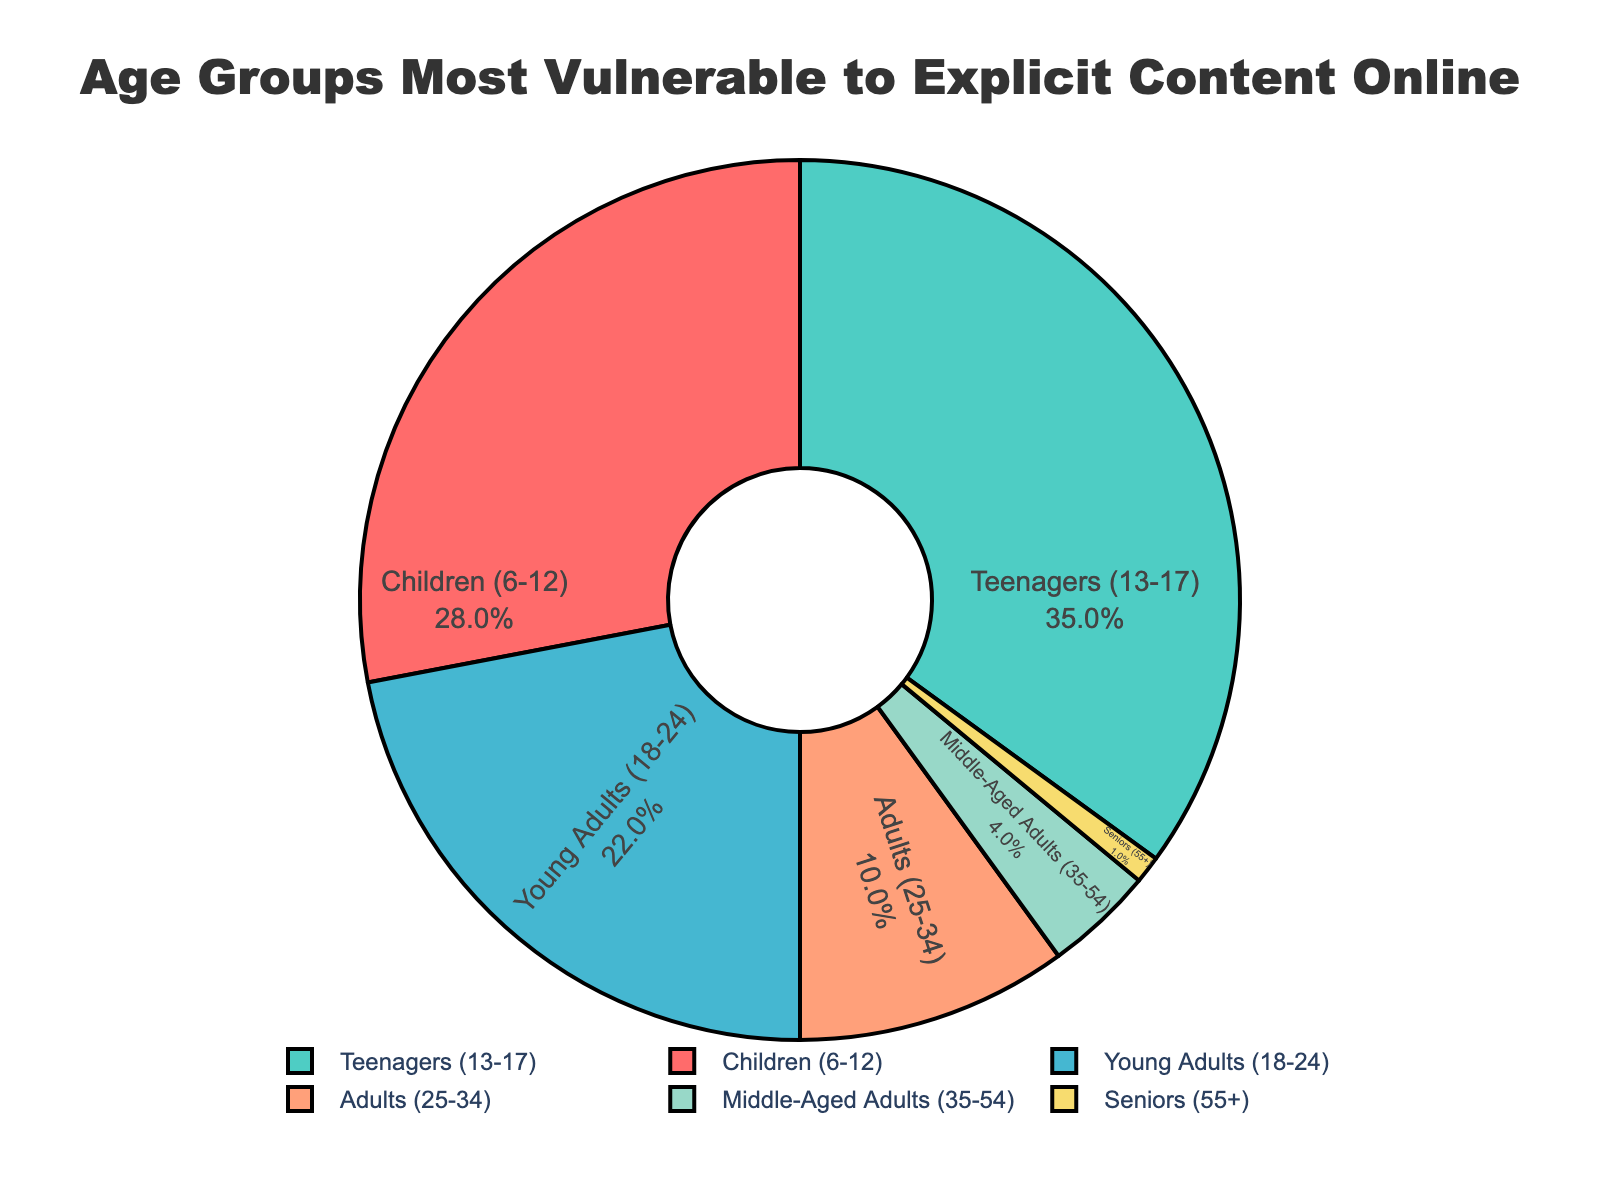Which age group is most vulnerable to explicit content online? The age group with the highest percentage is labeled on the pie chart. The largest segment representing 35% corresponds to Teenagers (13-17).
Answer: Teenagers (13-17) Which age group is the least vulnerable? The age group with the smallest percentage is labeled as Seniors (55+) with only 1% on the pie chart.
Answer: Seniors (55+) What is the combined percentage of Children and Teenagers? Sum the percentages of Children (28%) and Teenagers (35%). 28 + 35 equals 63%.
Answer: 63% Which has a higher percentage, Young Adults or Adults? Compare the percentages of Young Adults (22%) and Adults (10%) using the pie chart. Young Adults at 22% are higher than Adults at 10%.
Answer: Young Adults How much higher in percentage are Teenagers compared to Middle-Aged Adults? Subtract Middle-Aged Adults' percentage (4%) from Teenagers' percentage (35%). 35 - 4 equals 31%.
Answer: 31% What color represents the Teenagers group on the pie chart? Locate the color of the largest segment, which represents Teenagers at 35%, this segment is green.
Answer: Green Combine the percentages of Young Adults and Adults, then compare it to the percentage of Teenagers. Which is higher? Sum the percentages of Young Adults (22%) and Adults (10%) which is 32%. Compare this to Teenagers' 35%. Teenagers' percentage is higher.
Answer: Teenagers If the percentages of Young Adults and Middle-Aged Adults are added, do they surpass the percentage of Teenagers? Sum Young Adults (22%) and Middle-Aged Adults (4%). 22 + 4 equals 26%. Teenagers' 35% is still higher.
Answer: No By how much do Children and Young Adults combined exceed Adults and Middle-Aged Adults combined? Sum Children (28%) and Young Adults (22%) to get 50%. Sum Adults (10%) and Middle-Aged Adults (4%) to get 14%. Subtract 14 from 50. 50 - 14 equals 36%.
Answer: 36% Which age groups combined constitute less than 10% of the pie chart? Add the percentages for Middle-Aged Adults (4%) and Seniors (1%). 4 + 1 equals 5%, which is less than 10%.
Answer: Middle-Aged Adults and Seniors 